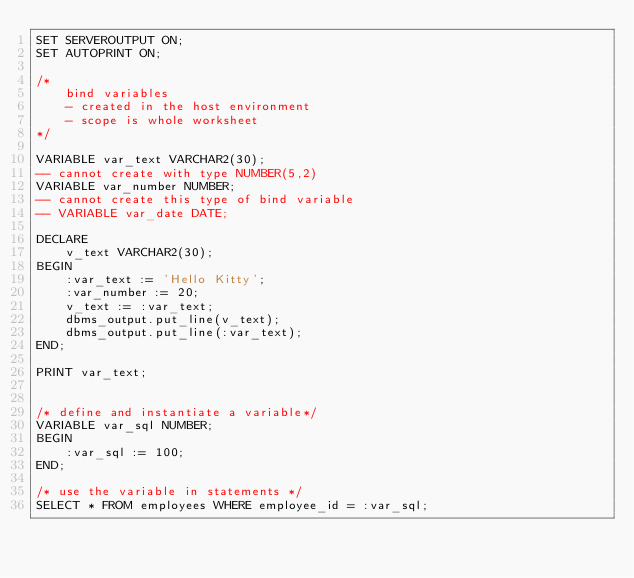Convert code to text. <code><loc_0><loc_0><loc_500><loc_500><_SQL_>SET SERVEROUTPUT ON;
SET AUTOPRINT ON;

/*
    bind variables
    - created in the host environment
    - scope is whole worksheet
*/

VARIABLE var_text VARCHAR2(30);
-- cannot create with type NUMBER(5,2)
VARIABLE var_number NUMBER;
-- cannot create this type of bind variable
-- VARIABLE var_date DATE; 

DECLARE
    v_text VARCHAR2(30);
BEGIN
    :var_text := 'Hello Kitty';
    :var_number := 20;
    v_text := :var_text;
    dbms_output.put_line(v_text);
    dbms_output.put_line(:var_text);
END;

PRINT var_text;


/* define and instantiate a variable*/
VARIABLE var_sql NUMBER;
BEGIN
    :var_sql := 100;
END;

/* use the variable in statements */
SELECT * FROM employees WHERE employee_id = :var_sql;</code> 